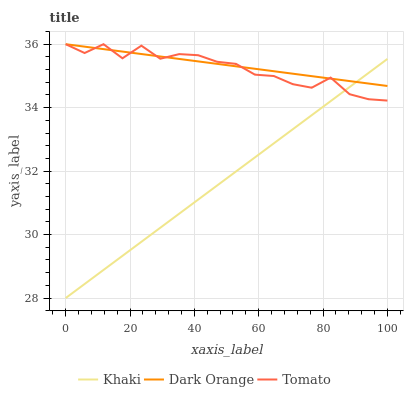Does Khaki have the minimum area under the curve?
Answer yes or no. Yes. Does Dark Orange have the maximum area under the curve?
Answer yes or no. Yes. Does Dark Orange have the minimum area under the curve?
Answer yes or no. No. Does Khaki have the maximum area under the curve?
Answer yes or no. No. Is Khaki the smoothest?
Answer yes or no. Yes. Is Tomato the roughest?
Answer yes or no. Yes. Is Dark Orange the smoothest?
Answer yes or no. No. Is Dark Orange the roughest?
Answer yes or no. No. Does Khaki have the lowest value?
Answer yes or no. Yes. Does Dark Orange have the lowest value?
Answer yes or no. No. Does Dark Orange have the highest value?
Answer yes or no. Yes. Does Khaki have the highest value?
Answer yes or no. No. Does Dark Orange intersect Khaki?
Answer yes or no. Yes. Is Dark Orange less than Khaki?
Answer yes or no. No. Is Dark Orange greater than Khaki?
Answer yes or no. No. 